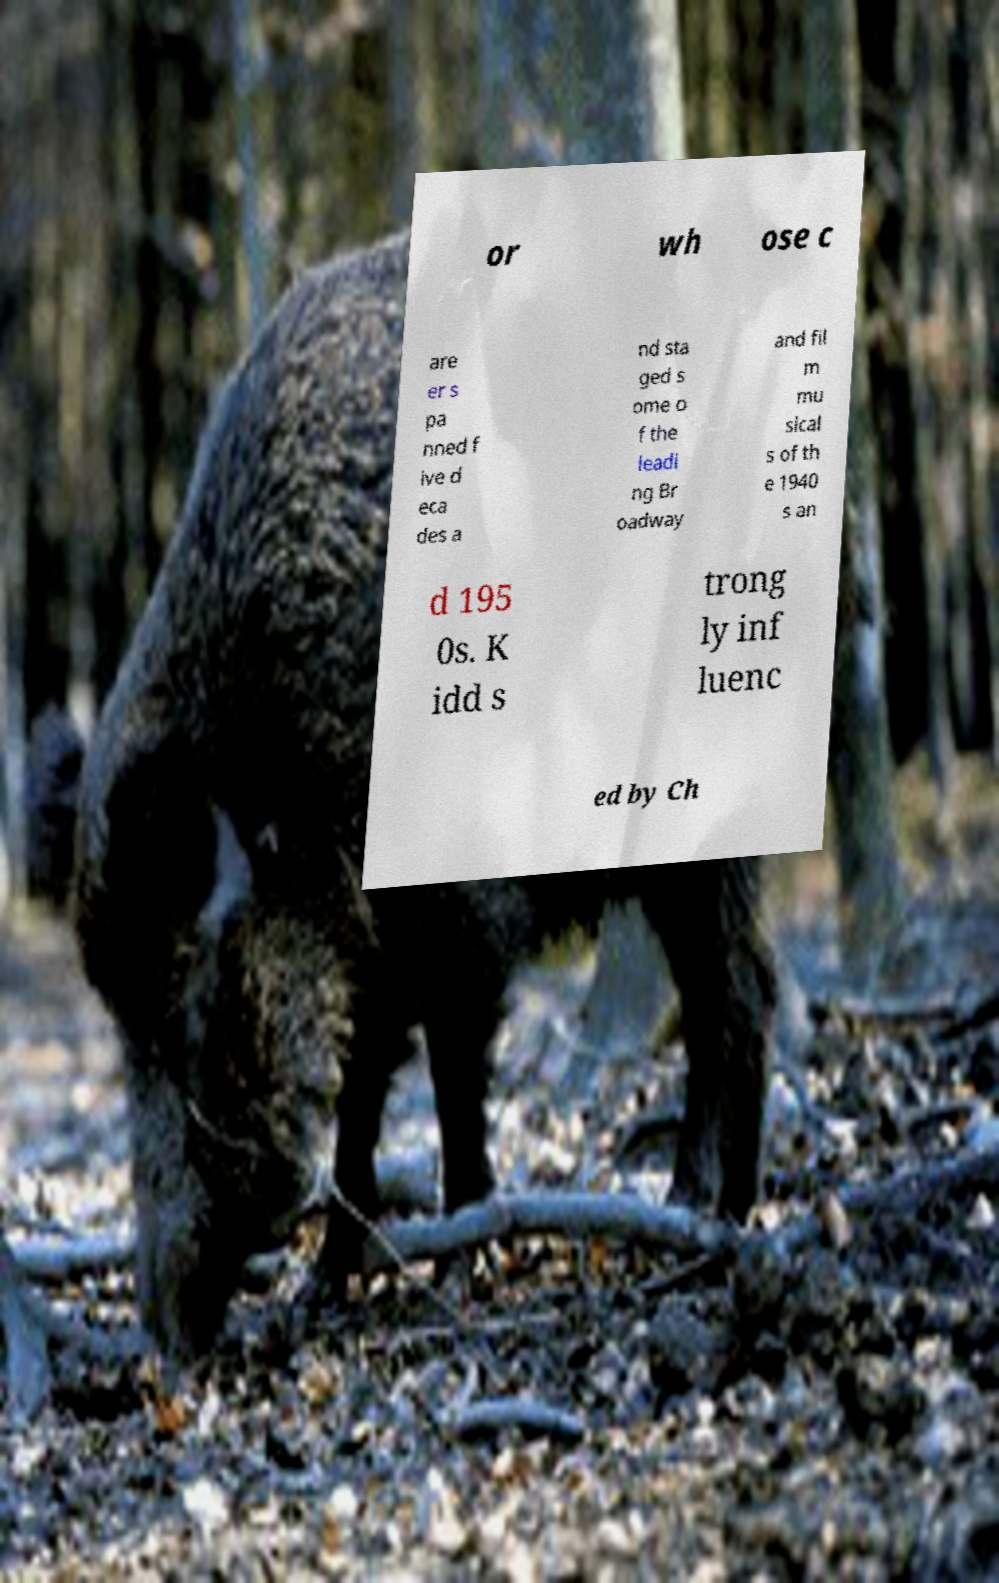There's text embedded in this image that I need extracted. Can you transcribe it verbatim? or wh ose c are er s pa nned f ive d eca des a nd sta ged s ome o f the leadi ng Br oadway and fil m mu sical s of th e 1940 s an d 195 0s. K idd s trong ly inf luenc ed by Ch 